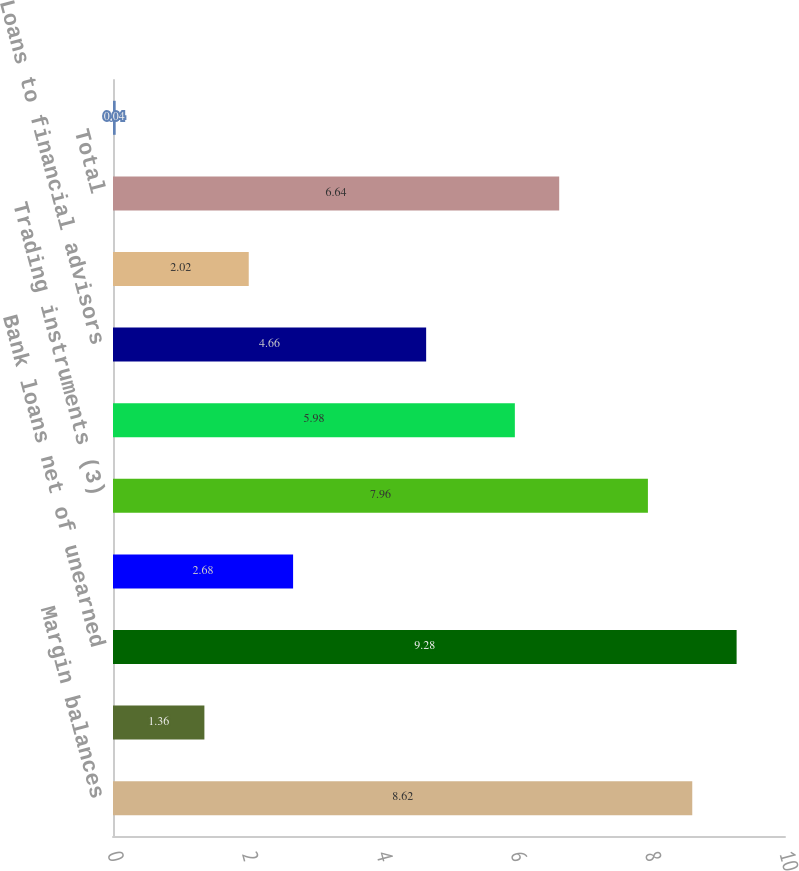Convert chart. <chart><loc_0><loc_0><loc_500><loc_500><bar_chart><fcel>Margin balances<fcel>Assets segregated pursuant to<fcel>Bank loans net of unearned<fcel>Available for sale securities<fcel>Trading instruments (3)<fcel>Stock loan<fcel>Loans to financial advisors<fcel>Corporate cash and all other<fcel>Total<fcel>Brokerage client liabilities<nl><fcel>8.62<fcel>1.36<fcel>9.28<fcel>2.68<fcel>7.96<fcel>5.98<fcel>4.66<fcel>2.02<fcel>6.64<fcel>0.04<nl></chart> 